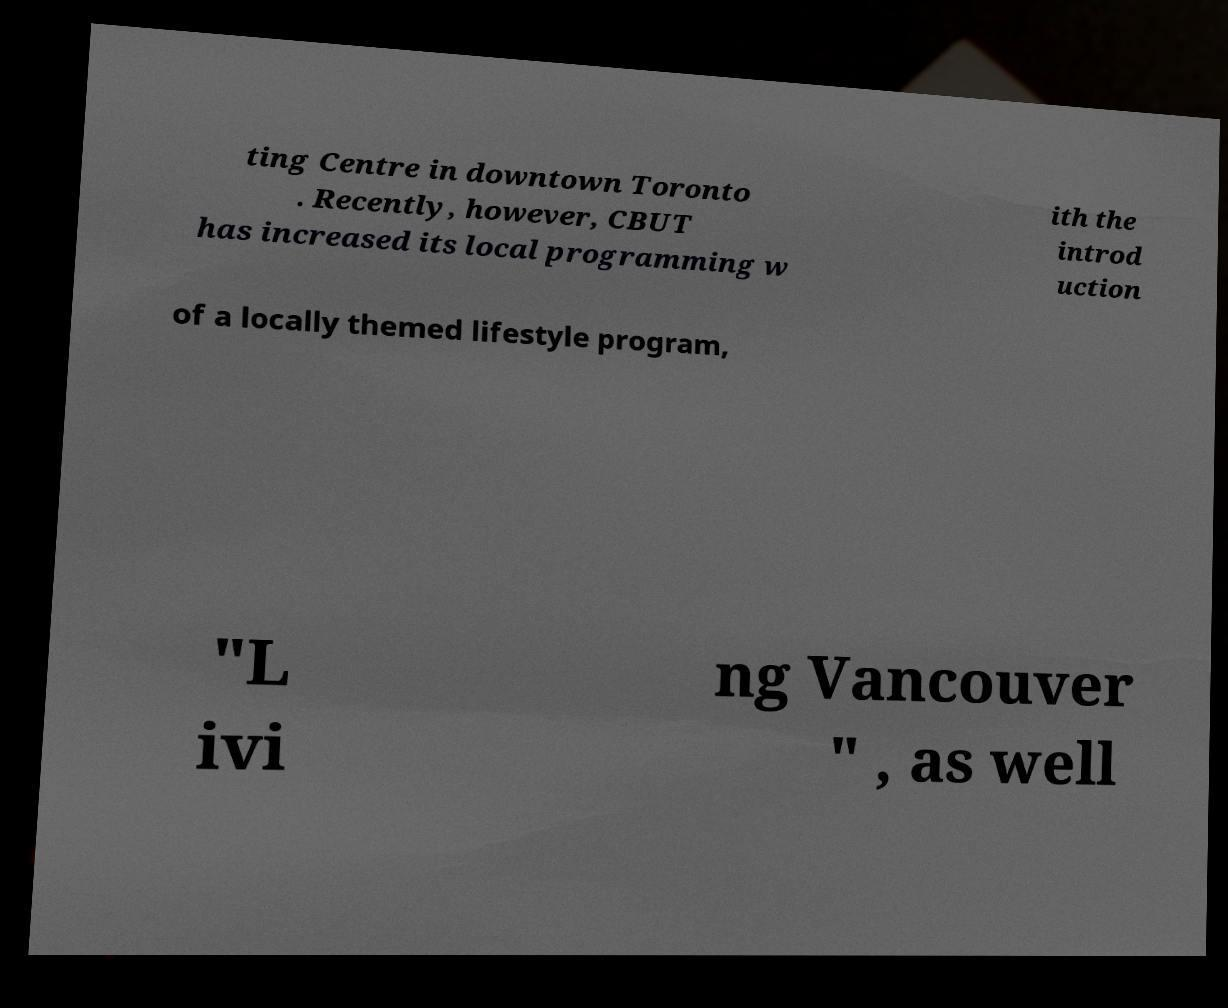There's text embedded in this image that I need extracted. Can you transcribe it verbatim? ting Centre in downtown Toronto . Recently, however, CBUT has increased its local programming w ith the introd uction of a locally themed lifestyle program, "L ivi ng Vancouver " , as well 